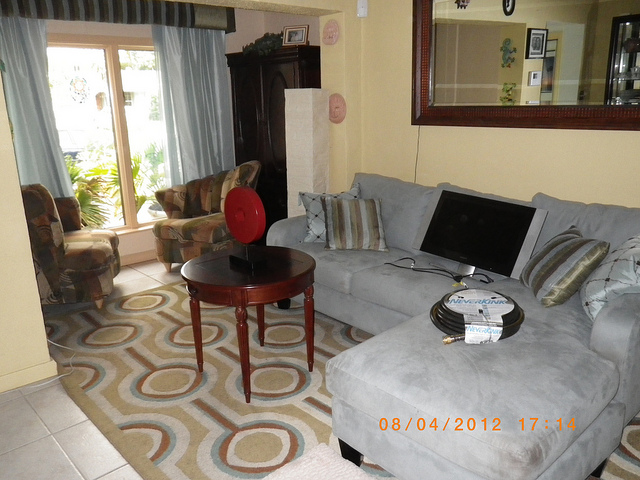Extract all visible text content from this image. 17 : 14 08/04/2012 